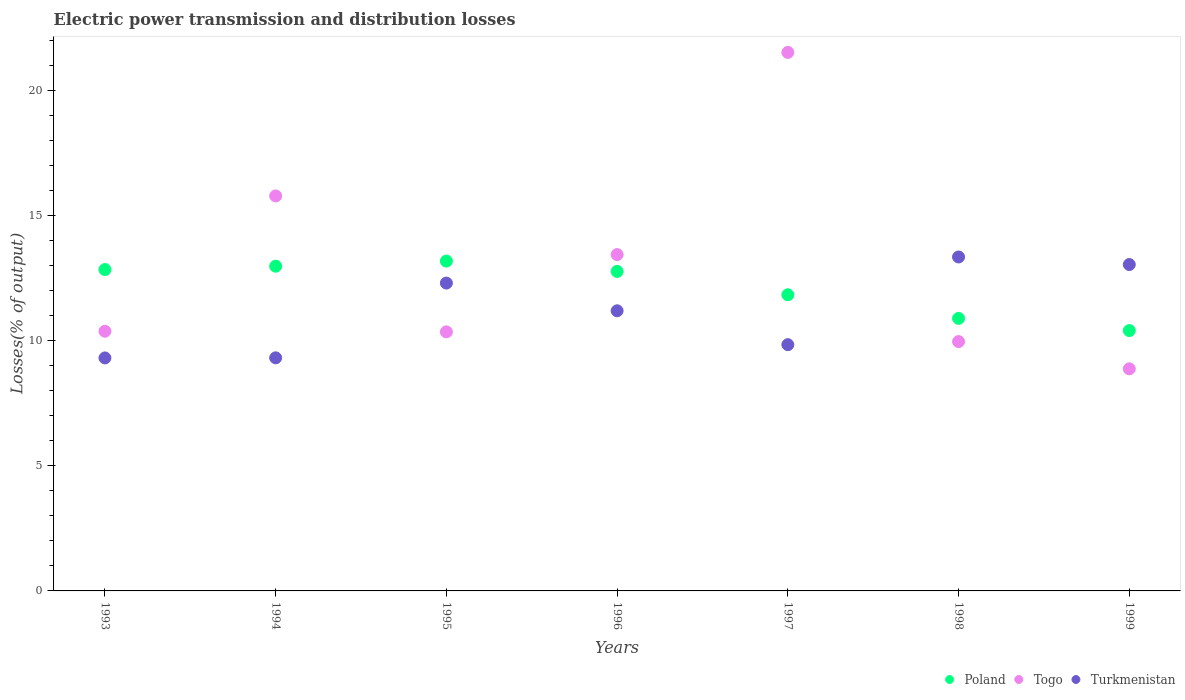How many different coloured dotlines are there?
Keep it short and to the point. 3. What is the electric power transmission and distribution losses in Togo in 1997?
Offer a very short reply. 21.53. Across all years, what is the maximum electric power transmission and distribution losses in Poland?
Offer a very short reply. 13.19. Across all years, what is the minimum electric power transmission and distribution losses in Turkmenistan?
Your answer should be compact. 9.31. In which year was the electric power transmission and distribution losses in Poland maximum?
Provide a short and direct response. 1995. In which year was the electric power transmission and distribution losses in Togo minimum?
Ensure brevity in your answer.  1999. What is the total electric power transmission and distribution losses in Poland in the graph?
Make the answer very short. 84.93. What is the difference between the electric power transmission and distribution losses in Togo in 1993 and that in 1996?
Give a very brief answer. -3.06. What is the difference between the electric power transmission and distribution losses in Poland in 1998 and the electric power transmission and distribution losses in Togo in 1996?
Give a very brief answer. -2.55. What is the average electric power transmission and distribution losses in Togo per year?
Give a very brief answer. 12.91. In the year 1994, what is the difference between the electric power transmission and distribution losses in Turkmenistan and electric power transmission and distribution losses in Poland?
Your answer should be very brief. -3.66. In how many years, is the electric power transmission and distribution losses in Turkmenistan greater than 13 %?
Provide a short and direct response. 2. What is the ratio of the electric power transmission and distribution losses in Turkmenistan in 1994 to that in 1997?
Give a very brief answer. 0.95. Is the electric power transmission and distribution losses in Turkmenistan in 1993 less than that in 1994?
Keep it short and to the point. Yes. What is the difference between the highest and the second highest electric power transmission and distribution losses in Turkmenistan?
Keep it short and to the point. 0.3. What is the difference between the highest and the lowest electric power transmission and distribution losses in Togo?
Provide a succinct answer. 12.65. In how many years, is the electric power transmission and distribution losses in Togo greater than the average electric power transmission and distribution losses in Togo taken over all years?
Ensure brevity in your answer.  3. Is the sum of the electric power transmission and distribution losses in Togo in 1993 and 1996 greater than the maximum electric power transmission and distribution losses in Poland across all years?
Provide a short and direct response. Yes. Is it the case that in every year, the sum of the electric power transmission and distribution losses in Togo and electric power transmission and distribution losses in Poland  is greater than the electric power transmission and distribution losses in Turkmenistan?
Make the answer very short. Yes. What is the difference between two consecutive major ticks on the Y-axis?
Offer a very short reply. 5. Are the values on the major ticks of Y-axis written in scientific E-notation?
Provide a succinct answer. No. Does the graph contain any zero values?
Your answer should be very brief. No. Does the graph contain grids?
Offer a terse response. No. How many legend labels are there?
Your answer should be compact. 3. What is the title of the graph?
Offer a terse response. Electric power transmission and distribution losses. What is the label or title of the X-axis?
Your answer should be very brief. Years. What is the label or title of the Y-axis?
Offer a very short reply. Losses(% of output). What is the Losses(% of output) in Poland in 1993?
Your answer should be very brief. 12.85. What is the Losses(% of output) of Togo in 1993?
Offer a very short reply. 10.38. What is the Losses(% of output) of Turkmenistan in 1993?
Keep it short and to the point. 9.31. What is the Losses(% of output) in Poland in 1994?
Ensure brevity in your answer.  12.98. What is the Losses(% of output) of Togo in 1994?
Ensure brevity in your answer.  15.79. What is the Losses(% of output) of Turkmenistan in 1994?
Your response must be concise. 9.32. What is the Losses(% of output) in Poland in 1995?
Offer a very short reply. 13.19. What is the Losses(% of output) of Togo in 1995?
Your response must be concise. 10.36. What is the Losses(% of output) of Turkmenistan in 1995?
Ensure brevity in your answer.  12.31. What is the Losses(% of output) in Poland in 1996?
Ensure brevity in your answer.  12.77. What is the Losses(% of output) of Togo in 1996?
Your response must be concise. 13.45. What is the Losses(% of output) of Turkmenistan in 1996?
Your response must be concise. 11.2. What is the Losses(% of output) of Poland in 1997?
Your response must be concise. 11.84. What is the Losses(% of output) in Togo in 1997?
Keep it short and to the point. 21.53. What is the Losses(% of output) of Turkmenistan in 1997?
Your answer should be compact. 9.84. What is the Losses(% of output) of Poland in 1998?
Offer a terse response. 10.89. What is the Losses(% of output) in Togo in 1998?
Make the answer very short. 9.97. What is the Losses(% of output) in Turkmenistan in 1998?
Provide a succinct answer. 13.35. What is the Losses(% of output) of Poland in 1999?
Offer a very short reply. 10.41. What is the Losses(% of output) in Togo in 1999?
Your response must be concise. 8.88. What is the Losses(% of output) in Turkmenistan in 1999?
Provide a succinct answer. 13.05. Across all years, what is the maximum Losses(% of output) of Poland?
Ensure brevity in your answer.  13.19. Across all years, what is the maximum Losses(% of output) in Togo?
Your response must be concise. 21.53. Across all years, what is the maximum Losses(% of output) in Turkmenistan?
Your response must be concise. 13.35. Across all years, what is the minimum Losses(% of output) of Poland?
Your answer should be compact. 10.41. Across all years, what is the minimum Losses(% of output) in Togo?
Provide a succinct answer. 8.88. Across all years, what is the minimum Losses(% of output) of Turkmenistan?
Provide a short and direct response. 9.31. What is the total Losses(% of output) in Poland in the graph?
Give a very brief answer. 84.93. What is the total Losses(% of output) of Togo in the graph?
Make the answer very short. 90.34. What is the total Losses(% of output) of Turkmenistan in the graph?
Offer a terse response. 78.38. What is the difference between the Losses(% of output) of Poland in 1993 and that in 1994?
Provide a short and direct response. -0.13. What is the difference between the Losses(% of output) in Togo in 1993 and that in 1994?
Make the answer very short. -5.41. What is the difference between the Losses(% of output) in Turkmenistan in 1993 and that in 1994?
Provide a succinct answer. -0. What is the difference between the Losses(% of output) in Poland in 1993 and that in 1995?
Provide a short and direct response. -0.34. What is the difference between the Losses(% of output) in Togo in 1993 and that in 1995?
Provide a short and direct response. 0.02. What is the difference between the Losses(% of output) in Turkmenistan in 1993 and that in 1995?
Offer a very short reply. -2.99. What is the difference between the Losses(% of output) of Poland in 1993 and that in 1996?
Keep it short and to the point. 0.07. What is the difference between the Losses(% of output) of Togo in 1993 and that in 1996?
Provide a short and direct response. -3.06. What is the difference between the Losses(% of output) of Turkmenistan in 1993 and that in 1996?
Your answer should be very brief. -1.88. What is the difference between the Losses(% of output) of Poland in 1993 and that in 1997?
Offer a very short reply. 1.01. What is the difference between the Losses(% of output) in Togo in 1993 and that in 1997?
Provide a short and direct response. -11.15. What is the difference between the Losses(% of output) of Turkmenistan in 1993 and that in 1997?
Keep it short and to the point. -0.53. What is the difference between the Losses(% of output) in Poland in 1993 and that in 1998?
Offer a very short reply. 1.95. What is the difference between the Losses(% of output) in Togo in 1993 and that in 1998?
Keep it short and to the point. 0.41. What is the difference between the Losses(% of output) of Turkmenistan in 1993 and that in 1998?
Provide a short and direct response. -4.04. What is the difference between the Losses(% of output) of Poland in 1993 and that in 1999?
Your response must be concise. 2.44. What is the difference between the Losses(% of output) of Togo in 1993 and that in 1999?
Offer a very short reply. 1.5. What is the difference between the Losses(% of output) of Turkmenistan in 1993 and that in 1999?
Make the answer very short. -3.73. What is the difference between the Losses(% of output) of Poland in 1994 and that in 1995?
Offer a very short reply. -0.2. What is the difference between the Losses(% of output) in Togo in 1994 and that in 1995?
Keep it short and to the point. 5.43. What is the difference between the Losses(% of output) in Turkmenistan in 1994 and that in 1995?
Offer a very short reply. -2.99. What is the difference between the Losses(% of output) in Poland in 1994 and that in 1996?
Your response must be concise. 0.21. What is the difference between the Losses(% of output) of Togo in 1994 and that in 1996?
Provide a succinct answer. 2.34. What is the difference between the Losses(% of output) of Turkmenistan in 1994 and that in 1996?
Offer a very short reply. -1.88. What is the difference between the Losses(% of output) of Poland in 1994 and that in 1997?
Your answer should be compact. 1.14. What is the difference between the Losses(% of output) in Togo in 1994 and that in 1997?
Provide a succinct answer. -5.74. What is the difference between the Losses(% of output) in Turkmenistan in 1994 and that in 1997?
Make the answer very short. -0.53. What is the difference between the Losses(% of output) in Poland in 1994 and that in 1998?
Provide a short and direct response. 2.09. What is the difference between the Losses(% of output) in Togo in 1994 and that in 1998?
Make the answer very short. 5.82. What is the difference between the Losses(% of output) in Turkmenistan in 1994 and that in 1998?
Your answer should be very brief. -4.03. What is the difference between the Losses(% of output) in Poland in 1994 and that in 1999?
Your response must be concise. 2.57. What is the difference between the Losses(% of output) of Togo in 1994 and that in 1999?
Give a very brief answer. 6.91. What is the difference between the Losses(% of output) of Turkmenistan in 1994 and that in 1999?
Offer a very short reply. -3.73. What is the difference between the Losses(% of output) of Poland in 1995 and that in 1996?
Ensure brevity in your answer.  0.41. What is the difference between the Losses(% of output) of Togo in 1995 and that in 1996?
Give a very brief answer. -3.09. What is the difference between the Losses(% of output) in Turkmenistan in 1995 and that in 1996?
Your response must be concise. 1.11. What is the difference between the Losses(% of output) of Poland in 1995 and that in 1997?
Give a very brief answer. 1.35. What is the difference between the Losses(% of output) in Togo in 1995 and that in 1997?
Make the answer very short. -11.17. What is the difference between the Losses(% of output) in Turkmenistan in 1995 and that in 1997?
Offer a very short reply. 2.46. What is the difference between the Losses(% of output) of Poland in 1995 and that in 1998?
Offer a terse response. 2.29. What is the difference between the Losses(% of output) in Togo in 1995 and that in 1998?
Provide a succinct answer. 0.39. What is the difference between the Losses(% of output) of Turkmenistan in 1995 and that in 1998?
Provide a short and direct response. -1.04. What is the difference between the Losses(% of output) in Poland in 1995 and that in 1999?
Your answer should be very brief. 2.78. What is the difference between the Losses(% of output) in Togo in 1995 and that in 1999?
Make the answer very short. 1.48. What is the difference between the Losses(% of output) in Turkmenistan in 1995 and that in 1999?
Ensure brevity in your answer.  -0.74. What is the difference between the Losses(% of output) in Poland in 1996 and that in 1997?
Your response must be concise. 0.93. What is the difference between the Losses(% of output) in Togo in 1996 and that in 1997?
Your answer should be very brief. -8.08. What is the difference between the Losses(% of output) in Turkmenistan in 1996 and that in 1997?
Your answer should be compact. 1.35. What is the difference between the Losses(% of output) of Poland in 1996 and that in 1998?
Give a very brief answer. 1.88. What is the difference between the Losses(% of output) in Togo in 1996 and that in 1998?
Your answer should be very brief. 3.48. What is the difference between the Losses(% of output) in Turkmenistan in 1996 and that in 1998?
Provide a succinct answer. -2.15. What is the difference between the Losses(% of output) in Poland in 1996 and that in 1999?
Keep it short and to the point. 2.36. What is the difference between the Losses(% of output) in Togo in 1996 and that in 1999?
Give a very brief answer. 4.57. What is the difference between the Losses(% of output) of Turkmenistan in 1996 and that in 1999?
Keep it short and to the point. -1.85. What is the difference between the Losses(% of output) of Poland in 1997 and that in 1998?
Ensure brevity in your answer.  0.94. What is the difference between the Losses(% of output) in Togo in 1997 and that in 1998?
Your response must be concise. 11.56. What is the difference between the Losses(% of output) of Turkmenistan in 1997 and that in 1998?
Ensure brevity in your answer.  -3.51. What is the difference between the Losses(% of output) in Poland in 1997 and that in 1999?
Make the answer very short. 1.43. What is the difference between the Losses(% of output) in Togo in 1997 and that in 1999?
Offer a terse response. 12.65. What is the difference between the Losses(% of output) of Turkmenistan in 1997 and that in 1999?
Provide a succinct answer. -3.2. What is the difference between the Losses(% of output) in Poland in 1998 and that in 1999?
Offer a terse response. 0.49. What is the difference between the Losses(% of output) in Togo in 1998 and that in 1999?
Your answer should be very brief. 1.09. What is the difference between the Losses(% of output) in Turkmenistan in 1998 and that in 1999?
Your answer should be compact. 0.3. What is the difference between the Losses(% of output) of Poland in 1993 and the Losses(% of output) of Togo in 1994?
Offer a terse response. -2.94. What is the difference between the Losses(% of output) of Poland in 1993 and the Losses(% of output) of Turkmenistan in 1994?
Give a very brief answer. 3.53. What is the difference between the Losses(% of output) in Togo in 1993 and the Losses(% of output) in Turkmenistan in 1994?
Provide a succinct answer. 1.06. What is the difference between the Losses(% of output) of Poland in 1993 and the Losses(% of output) of Togo in 1995?
Provide a succinct answer. 2.49. What is the difference between the Losses(% of output) of Poland in 1993 and the Losses(% of output) of Turkmenistan in 1995?
Provide a short and direct response. 0.54. What is the difference between the Losses(% of output) in Togo in 1993 and the Losses(% of output) in Turkmenistan in 1995?
Provide a short and direct response. -1.93. What is the difference between the Losses(% of output) in Poland in 1993 and the Losses(% of output) in Togo in 1996?
Provide a short and direct response. -0.6. What is the difference between the Losses(% of output) of Poland in 1993 and the Losses(% of output) of Turkmenistan in 1996?
Give a very brief answer. 1.65. What is the difference between the Losses(% of output) in Togo in 1993 and the Losses(% of output) in Turkmenistan in 1996?
Provide a short and direct response. -0.82. What is the difference between the Losses(% of output) of Poland in 1993 and the Losses(% of output) of Togo in 1997?
Provide a succinct answer. -8.68. What is the difference between the Losses(% of output) in Poland in 1993 and the Losses(% of output) in Turkmenistan in 1997?
Give a very brief answer. 3. What is the difference between the Losses(% of output) in Togo in 1993 and the Losses(% of output) in Turkmenistan in 1997?
Give a very brief answer. 0.54. What is the difference between the Losses(% of output) in Poland in 1993 and the Losses(% of output) in Togo in 1998?
Your answer should be compact. 2.88. What is the difference between the Losses(% of output) in Poland in 1993 and the Losses(% of output) in Turkmenistan in 1998?
Ensure brevity in your answer.  -0.5. What is the difference between the Losses(% of output) in Togo in 1993 and the Losses(% of output) in Turkmenistan in 1998?
Keep it short and to the point. -2.97. What is the difference between the Losses(% of output) of Poland in 1993 and the Losses(% of output) of Togo in 1999?
Make the answer very short. 3.97. What is the difference between the Losses(% of output) in Poland in 1993 and the Losses(% of output) in Turkmenistan in 1999?
Offer a very short reply. -0.2. What is the difference between the Losses(% of output) of Togo in 1993 and the Losses(% of output) of Turkmenistan in 1999?
Keep it short and to the point. -2.67. What is the difference between the Losses(% of output) of Poland in 1994 and the Losses(% of output) of Togo in 1995?
Provide a short and direct response. 2.63. What is the difference between the Losses(% of output) of Poland in 1994 and the Losses(% of output) of Turkmenistan in 1995?
Make the answer very short. 0.68. What is the difference between the Losses(% of output) of Togo in 1994 and the Losses(% of output) of Turkmenistan in 1995?
Give a very brief answer. 3.48. What is the difference between the Losses(% of output) of Poland in 1994 and the Losses(% of output) of Togo in 1996?
Keep it short and to the point. -0.46. What is the difference between the Losses(% of output) in Poland in 1994 and the Losses(% of output) in Turkmenistan in 1996?
Keep it short and to the point. 1.78. What is the difference between the Losses(% of output) in Togo in 1994 and the Losses(% of output) in Turkmenistan in 1996?
Keep it short and to the point. 4.59. What is the difference between the Losses(% of output) of Poland in 1994 and the Losses(% of output) of Togo in 1997?
Offer a very short reply. -8.55. What is the difference between the Losses(% of output) in Poland in 1994 and the Losses(% of output) in Turkmenistan in 1997?
Offer a terse response. 3.14. What is the difference between the Losses(% of output) in Togo in 1994 and the Losses(% of output) in Turkmenistan in 1997?
Your answer should be very brief. 5.95. What is the difference between the Losses(% of output) of Poland in 1994 and the Losses(% of output) of Togo in 1998?
Give a very brief answer. 3.01. What is the difference between the Losses(% of output) of Poland in 1994 and the Losses(% of output) of Turkmenistan in 1998?
Your answer should be very brief. -0.37. What is the difference between the Losses(% of output) of Togo in 1994 and the Losses(% of output) of Turkmenistan in 1998?
Make the answer very short. 2.44. What is the difference between the Losses(% of output) of Poland in 1994 and the Losses(% of output) of Togo in 1999?
Make the answer very short. 4.1. What is the difference between the Losses(% of output) in Poland in 1994 and the Losses(% of output) in Turkmenistan in 1999?
Ensure brevity in your answer.  -0.07. What is the difference between the Losses(% of output) in Togo in 1994 and the Losses(% of output) in Turkmenistan in 1999?
Your answer should be compact. 2.74. What is the difference between the Losses(% of output) in Poland in 1995 and the Losses(% of output) in Togo in 1996?
Give a very brief answer. -0.26. What is the difference between the Losses(% of output) of Poland in 1995 and the Losses(% of output) of Turkmenistan in 1996?
Ensure brevity in your answer.  1.99. What is the difference between the Losses(% of output) in Togo in 1995 and the Losses(% of output) in Turkmenistan in 1996?
Keep it short and to the point. -0.84. What is the difference between the Losses(% of output) of Poland in 1995 and the Losses(% of output) of Togo in 1997?
Make the answer very short. -8.34. What is the difference between the Losses(% of output) of Poland in 1995 and the Losses(% of output) of Turkmenistan in 1997?
Your answer should be compact. 3.34. What is the difference between the Losses(% of output) in Togo in 1995 and the Losses(% of output) in Turkmenistan in 1997?
Make the answer very short. 0.51. What is the difference between the Losses(% of output) of Poland in 1995 and the Losses(% of output) of Togo in 1998?
Your answer should be very brief. 3.22. What is the difference between the Losses(% of output) in Poland in 1995 and the Losses(% of output) in Turkmenistan in 1998?
Make the answer very short. -0.16. What is the difference between the Losses(% of output) in Togo in 1995 and the Losses(% of output) in Turkmenistan in 1998?
Ensure brevity in your answer.  -2.99. What is the difference between the Losses(% of output) of Poland in 1995 and the Losses(% of output) of Togo in 1999?
Keep it short and to the point. 4.31. What is the difference between the Losses(% of output) of Poland in 1995 and the Losses(% of output) of Turkmenistan in 1999?
Provide a succinct answer. 0.14. What is the difference between the Losses(% of output) in Togo in 1995 and the Losses(% of output) in Turkmenistan in 1999?
Your answer should be compact. -2.69. What is the difference between the Losses(% of output) in Poland in 1996 and the Losses(% of output) in Togo in 1997?
Ensure brevity in your answer.  -8.76. What is the difference between the Losses(% of output) in Poland in 1996 and the Losses(% of output) in Turkmenistan in 1997?
Make the answer very short. 2.93. What is the difference between the Losses(% of output) in Togo in 1996 and the Losses(% of output) in Turkmenistan in 1997?
Your answer should be compact. 3.6. What is the difference between the Losses(% of output) of Poland in 1996 and the Losses(% of output) of Togo in 1998?
Provide a succinct answer. 2.81. What is the difference between the Losses(% of output) in Poland in 1996 and the Losses(% of output) in Turkmenistan in 1998?
Give a very brief answer. -0.58. What is the difference between the Losses(% of output) of Togo in 1996 and the Losses(% of output) of Turkmenistan in 1998?
Provide a succinct answer. 0.1. What is the difference between the Losses(% of output) in Poland in 1996 and the Losses(% of output) in Togo in 1999?
Ensure brevity in your answer.  3.89. What is the difference between the Losses(% of output) in Poland in 1996 and the Losses(% of output) in Turkmenistan in 1999?
Provide a succinct answer. -0.28. What is the difference between the Losses(% of output) of Togo in 1996 and the Losses(% of output) of Turkmenistan in 1999?
Keep it short and to the point. 0.4. What is the difference between the Losses(% of output) in Poland in 1997 and the Losses(% of output) in Togo in 1998?
Make the answer very short. 1.87. What is the difference between the Losses(% of output) in Poland in 1997 and the Losses(% of output) in Turkmenistan in 1998?
Your answer should be compact. -1.51. What is the difference between the Losses(% of output) of Togo in 1997 and the Losses(% of output) of Turkmenistan in 1998?
Your answer should be compact. 8.18. What is the difference between the Losses(% of output) in Poland in 1997 and the Losses(% of output) in Togo in 1999?
Your response must be concise. 2.96. What is the difference between the Losses(% of output) of Poland in 1997 and the Losses(% of output) of Turkmenistan in 1999?
Give a very brief answer. -1.21. What is the difference between the Losses(% of output) of Togo in 1997 and the Losses(% of output) of Turkmenistan in 1999?
Your response must be concise. 8.48. What is the difference between the Losses(% of output) of Poland in 1998 and the Losses(% of output) of Togo in 1999?
Your answer should be compact. 2.02. What is the difference between the Losses(% of output) of Poland in 1998 and the Losses(% of output) of Turkmenistan in 1999?
Your answer should be compact. -2.15. What is the difference between the Losses(% of output) of Togo in 1998 and the Losses(% of output) of Turkmenistan in 1999?
Provide a short and direct response. -3.08. What is the average Losses(% of output) in Poland per year?
Offer a terse response. 12.13. What is the average Losses(% of output) of Togo per year?
Your answer should be compact. 12.91. What is the average Losses(% of output) of Turkmenistan per year?
Provide a short and direct response. 11.2. In the year 1993, what is the difference between the Losses(% of output) of Poland and Losses(% of output) of Togo?
Provide a short and direct response. 2.47. In the year 1993, what is the difference between the Losses(% of output) in Poland and Losses(% of output) in Turkmenistan?
Keep it short and to the point. 3.53. In the year 1993, what is the difference between the Losses(% of output) in Togo and Losses(% of output) in Turkmenistan?
Provide a succinct answer. 1.07. In the year 1994, what is the difference between the Losses(% of output) of Poland and Losses(% of output) of Togo?
Provide a short and direct response. -2.81. In the year 1994, what is the difference between the Losses(% of output) of Poland and Losses(% of output) of Turkmenistan?
Your response must be concise. 3.66. In the year 1994, what is the difference between the Losses(% of output) of Togo and Losses(% of output) of Turkmenistan?
Give a very brief answer. 6.47. In the year 1995, what is the difference between the Losses(% of output) of Poland and Losses(% of output) of Togo?
Offer a very short reply. 2.83. In the year 1995, what is the difference between the Losses(% of output) in Poland and Losses(% of output) in Turkmenistan?
Your answer should be very brief. 0.88. In the year 1995, what is the difference between the Losses(% of output) in Togo and Losses(% of output) in Turkmenistan?
Your answer should be compact. -1.95. In the year 1996, what is the difference between the Losses(% of output) of Poland and Losses(% of output) of Togo?
Offer a very short reply. -0.67. In the year 1996, what is the difference between the Losses(% of output) of Poland and Losses(% of output) of Turkmenistan?
Make the answer very short. 1.57. In the year 1996, what is the difference between the Losses(% of output) of Togo and Losses(% of output) of Turkmenistan?
Make the answer very short. 2.25. In the year 1997, what is the difference between the Losses(% of output) of Poland and Losses(% of output) of Togo?
Offer a very short reply. -9.69. In the year 1997, what is the difference between the Losses(% of output) of Poland and Losses(% of output) of Turkmenistan?
Provide a short and direct response. 1.99. In the year 1997, what is the difference between the Losses(% of output) in Togo and Losses(% of output) in Turkmenistan?
Your answer should be compact. 11.68. In the year 1998, what is the difference between the Losses(% of output) of Poland and Losses(% of output) of Togo?
Provide a short and direct response. 0.93. In the year 1998, what is the difference between the Losses(% of output) of Poland and Losses(% of output) of Turkmenistan?
Make the answer very short. -2.45. In the year 1998, what is the difference between the Losses(% of output) in Togo and Losses(% of output) in Turkmenistan?
Give a very brief answer. -3.38. In the year 1999, what is the difference between the Losses(% of output) in Poland and Losses(% of output) in Togo?
Provide a short and direct response. 1.53. In the year 1999, what is the difference between the Losses(% of output) in Poland and Losses(% of output) in Turkmenistan?
Keep it short and to the point. -2.64. In the year 1999, what is the difference between the Losses(% of output) of Togo and Losses(% of output) of Turkmenistan?
Ensure brevity in your answer.  -4.17. What is the ratio of the Losses(% of output) of Togo in 1993 to that in 1994?
Provide a succinct answer. 0.66. What is the ratio of the Losses(% of output) in Turkmenistan in 1993 to that in 1994?
Ensure brevity in your answer.  1. What is the ratio of the Losses(% of output) of Poland in 1993 to that in 1995?
Give a very brief answer. 0.97. What is the ratio of the Losses(% of output) in Togo in 1993 to that in 1995?
Keep it short and to the point. 1. What is the ratio of the Losses(% of output) in Turkmenistan in 1993 to that in 1995?
Make the answer very short. 0.76. What is the ratio of the Losses(% of output) in Poland in 1993 to that in 1996?
Your answer should be very brief. 1.01. What is the ratio of the Losses(% of output) of Togo in 1993 to that in 1996?
Offer a terse response. 0.77. What is the ratio of the Losses(% of output) of Turkmenistan in 1993 to that in 1996?
Make the answer very short. 0.83. What is the ratio of the Losses(% of output) in Poland in 1993 to that in 1997?
Give a very brief answer. 1.09. What is the ratio of the Losses(% of output) of Togo in 1993 to that in 1997?
Provide a succinct answer. 0.48. What is the ratio of the Losses(% of output) in Turkmenistan in 1993 to that in 1997?
Your response must be concise. 0.95. What is the ratio of the Losses(% of output) in Poland in 1993 to that in 1998?
Your answer should be very brief. 1.18. What is the ratio of the Losses(% of output) of Togo in 1993 to that in 1998?
Your answer should be compact. 1.04. What is the ratio of the Losses(% of output) of Turkmenistan in 1993 to that in 1998?
Your response must be concise. 0.7. What is the ratio of the Losses(% of output) in Poland in 1993 to that in 1999?
Your response must be concise. 1.23. What is the ratio of the Losses(% of output) of Togo in 1993 to that in 1999?
Provide a short and direct response. 1.17. What is the ratio of the Losses(% of output) in Turkmenistan in 1993 to that in 1999?
Keep it short and to the point. 0.71. What is the ratio of the Losses(% of output) in Poland in 1994 to that in 1995?
Your answer should be compact. 0.98. What is the ratio of the Losses(% of output) in Togo in 1994 to that in 1995?
Your answer should be compact. 1.52. What is the ratio of the Losses(% of output) in Turkmenistan in 1994 to that in 1995?
Keep it short and to the point. 0.76. What is the ratio of the Losses(% of output) of Poland in 1994 to that in 1996?
Provide a succinct answer. 1.02. What is the ratio of the Losses(% of output) of Togo in 1994 to that in 1996?
Make the answer very short. 1.17. What is the ratio of the Losses(% of output) of Turkmenistan in 1994 to that in 1996?
Your response must be concise. 0.83. What is the ratio of the Losses(% of output) of Poland in 1994 to that in 1997?
Your answer should be very brief. 1.1. What is the ratio of the Losses(% of output) of Togo in 1994 to that in 1997?
Offer a terse response. 0.73. What is the ratio of the Losses(% of output) in Turkmenistan in 1994 to that in 1997?
Give a very brief answer. 0.95. What is the ratio of the Losses(% of output) in Poland in 1994 to that in 1998?
Ensure brevity in your answer.  1.19. What is the ratio of the Losses(% of output) of Togo in 1994 to that in 1998?
Offer a terse response. 1.58. What is the ratio of the Losses(% of output) of Turkmenistan in 1994 to that in 1998?
Your answer should be very brief. 0.7. What is the ratio of the Losses(% of output) of Poland in 1994 to that in 1999?
Offer a very short reply. 1.25. What is the ratio of the Losses(% of output) in Togo in 1994 to that in 1999?
Ensure brevity in your answer.  1.78. What is the ratio of the Losses(% of output) of Turkmenistan in 1994 to that in 1999?
Your response must be concise. 0.71. What is the ratio of the Losses(% of output) in Poland in 1995 to that in 1996?
Provide a succinct answer. 1.03. What is the ratio of the Losses(% of output) in Togo in 1995 to that in 1996?
Your answer should be very brief. 0.77. What is the ratio of the Losses(% of output) of Turkmenistan in 1995 to that in 1996?
Make the answer very short. 1.1. What is the ratio of the Losses(% of output) in Poland in 1995 to that in 1997?
Provide a short and direct response. 1.11. What is the ratio of the Losses(% of output) of Togo in 1995 to that in 1997?
Provide a succinct answer. 0.48. What is the ratio of the Losses(% of output) in Turkmenistan in 1995 to that in 1997?
Offer a very short reply. 1.25. What is the ratio of the Losses(% of output) of Poland in 1995 to that in 1998?
Ensure brevity in your answer.  1.21. What is the ratio of the Losses(% of output) in Togo in 1995 to that in 1998?
Offer a terse response. 1.04. What is the ratio of the Losses(% of output) of Turkmenistan in 1995 to that in 1998?
Your answer should be very brief. 0.92. What is the ratio of the Losses(% of output) in Poland in 1995 to that in 1999?
Your answer should be compact. 1.27. What is the ratio of the Losses(% of output) in Togo in 1995 to that in 1999?
Provide a short and direct response. 1.17. What is the ratio of the Losses(% of output) of Turkmenistan in 1995 to that in 1999?
Ensure brevity in your answer.  0.94. What is the ratio of the Losses(% of output) of Poland in 1996 to that in 1997?
Ensure brevity in your answer.  1.08. What is the ratio of the Losses(% of output) in Togo in 1996 to that in 1997?
Your response must be concise. 0.62. What is the ratio of the Losses(% of output) in Turkmenistan in 1996 to that in 1997?
Offer a terse response. 1.14. What is the ratio of the Losses(% of output) of Poland in 1996 to that in 1998?
Keep it short and to the point. 1.17. What is the ratio of the Losses(% of output) of Togo in 1996 to that in 1998?
Provide a succinct answer. 1.35. What is the ratio of the Losses(% of output) in Turkmenistan in 1996 to that in 1998?
Keep it short and to the point. 0.84. What is the ratio of the Losses(% of output) of Poland in 1996 to that in 1999?
Keep it short and to the point. 1.23. What is the ratio of the Losses(% of output) in Togo in 1996 to that in 1999?
Provide a succinct answer. 1.51. What is the ratio of the Losses(% of output) in Turkmenistan in 1996 to that in 1999?
Provide a short and direct response. 0.86. What is the ratio of the Losses(% of output) in Poland in 1997 to that in 1998?
Provide a short and direct response. 1.09. What is the ratio of the Losses(% of output) of Togo in 1997 to that in 1998?
Provide a short and direct response. 2.16. What is the ratio of the Losses(% of output) in Turkmenistan in 1997 to that in 1998?
Your answer should be very brief. 0.74. What is the ratio of the Losses(% of output) of Poland in 1997 to that in 1999?
Make the answer very short. 1.14. What is the ratio of the Losses(% of output) of Togo in 1997 to that in 1999?
Offer a terse response. 2.42. What is the ratio of the Losses(% of output) of Turkmenistan in 1997 to that in 1999?
Make the answer very short. 0.75. What is the ratio of the Losses(% of output) in Poland in 1998 to that in 1999?
Make the answer very short. 1.05. What is the ratio of the Losses(% of output) of Togo in 1998 to that in 1999?
Offer a very short reply. 1.12. What is the ratio of the Losses(% of output) of Turkmenistan in 1998 to that in 1999?
Make the answer very short. 1.02. What is the difference between the highest and the second highest Losses(% of output) of Poland?
Your answer should be compact. 0.2. What is the difference between the highest and the second highest Losses(% of output) in Togo?
Provide a succinct answer. 5.74. What is the difference between the highest and the second highest Losses(% of output) of Turkmenistan?
Give a very brief answer. 0.3. What is the difference between the highest and the lowest Losses(% of output) in Poland?
Your response must be concise. 2.78. What is the difference between the highest and the lowest Losses(% of output) in Togo?
Provide a succinct answer. 12.65. What is the difference between the highest and the lowest Losses(% of output) of Turkmenistan?
Give a very brief answer. 4.04. 